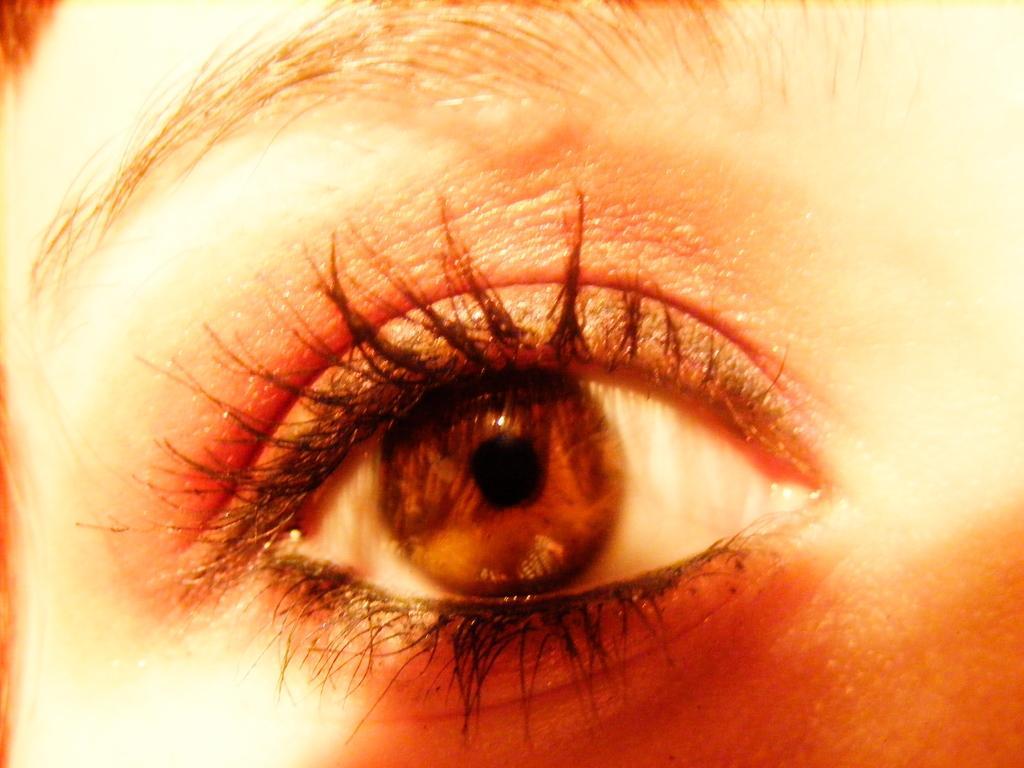How would you summarize this image in a sentence or two? In this picture there is a person and in the middle of the image there is an eye. At the top there is an eyebrow. 